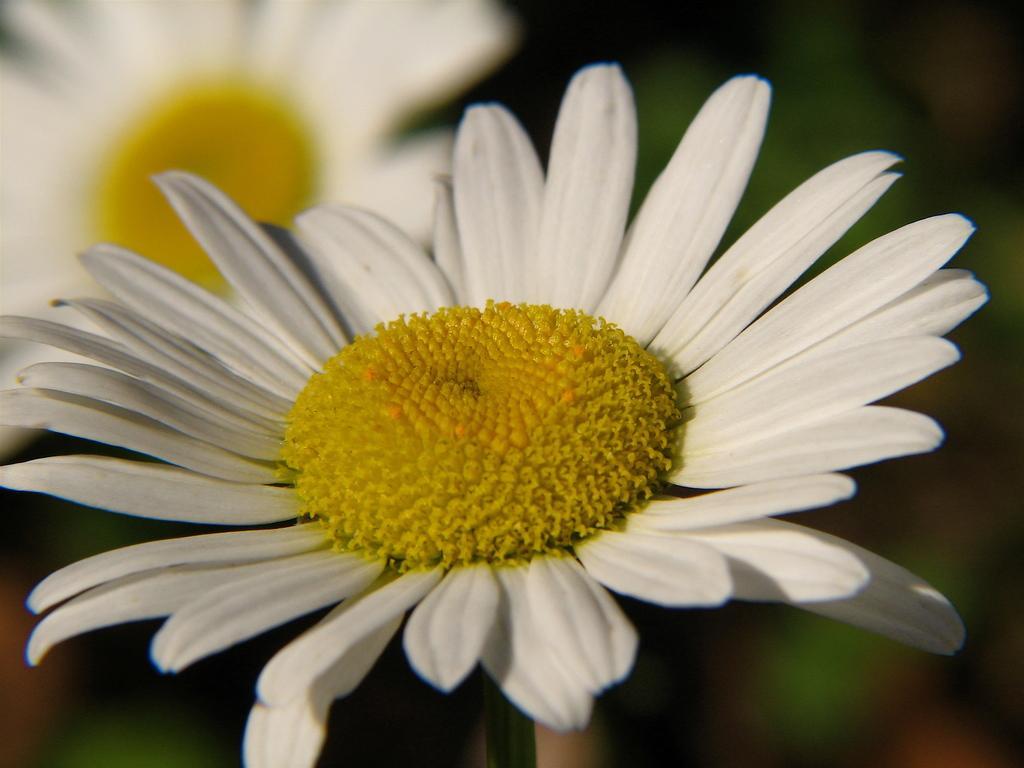Please provide a concise description of this image. In this picture I can observe white and yellow color flowers. The background is completely blurred. 